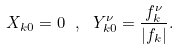<formula> <loc_0><loc_0><loc_500><loc_500>X _ { { k } 0 } = 0 \ , \ Y _ { { k } 0 } ^ { \nu } = \frac { f _ { k } ^ { \nu } } { | f _ { k } | } .</formula> 